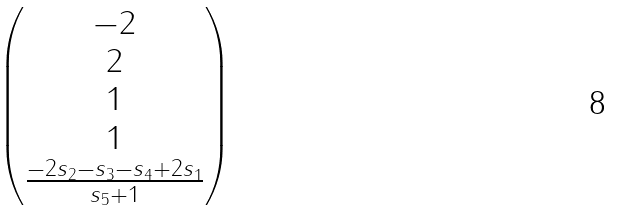Convert formula to latex. <formula><loc_0><loc_0><loc_500><loc_500>\begin{pmatrix} - 2 \\ 2 \\ 1 \\ 1 \\ \frac { - 2 s _ { 2 } - s _ { 3 } - s _ { 4 } + 2 s _ { 1 } } { s _ { 5 } + 1 } \end{pmatrix}</formula> 